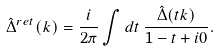<formula> <loc_0><loc_0><loc_500><loc_500>\hat { \Delta } ^ { r e t } ( k ) = \frac { i } { 2 \pi } \int d t \, \frac { \hat { \Delta } ( t k ) } { 1 - t + i 0 } .</formula> 